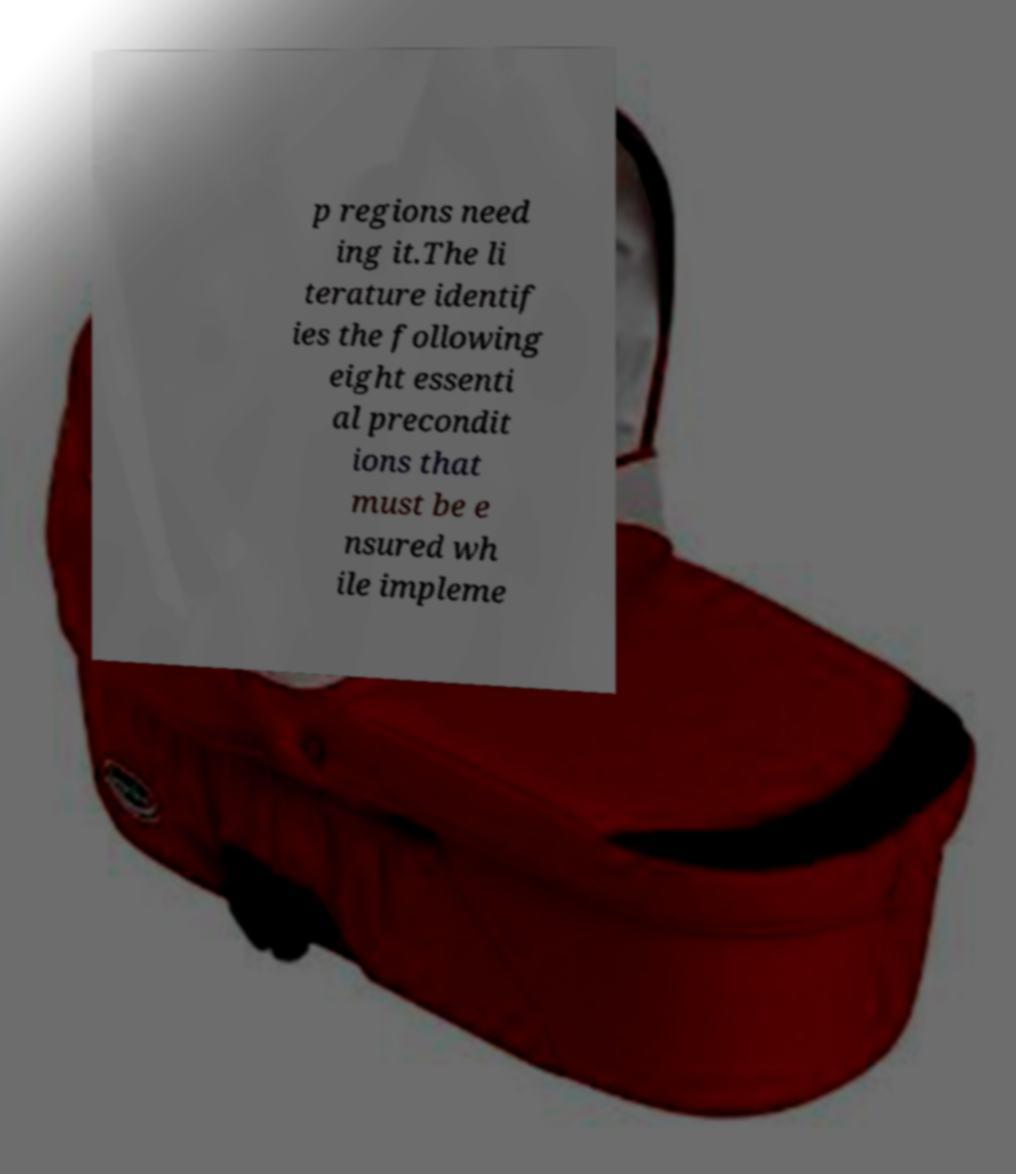Can you read and provide the text displayed in the image?This photo seems to have some interesting text. Can you extract and type it out for me? p regions need ing it.The li terature identif ies the following eight essenti al precondit ions that must be e nsured wh ile impleme 